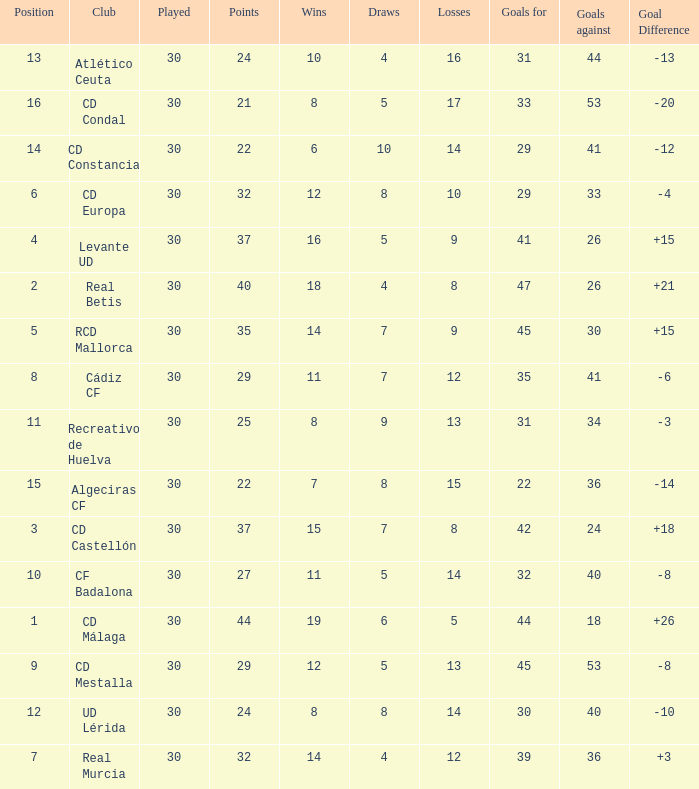What is the wins number when the points were smaller than 27, and goals against was 41? 6.0. 